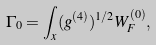Convert formula to latex. <formula><loc_0><loc_0><loc_500><loc_500>\Gamma _ { 0 } = \int _ { x } ( g ^ { ( 4 ) } ) ^ { 1 / 2 } W ^ { ( 0 ) } _ { F } ,</formula> 